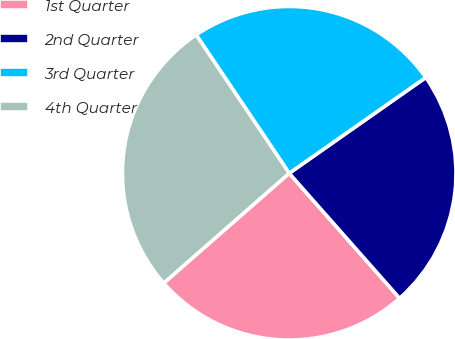<chart> <loc_0><loc_0><loc_500><loc_500><pie_chart><fcel>1st Quarter<fcel>2nd Quarter<fcel>3rd Quarter<fcel>4th Quarter<nl><fcel>25.07%<fcel>23.22%<fcel>24.69%<fcel>27.02%<nl></chart> 